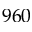<formula> <loc_0><loc_0><loc_500><loc_500>9 6 0</formula> 